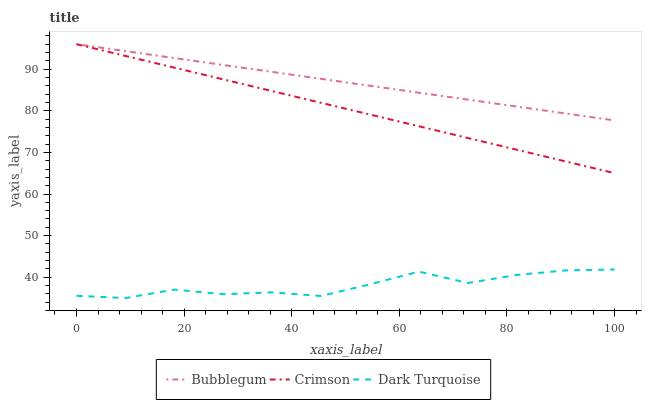Does Dark Turquoise have the minimum area under the curve?
Answer yes or no. Yes. Does Bubblegum have the maximum area under the curve?
Answer yes or no. Yes. Does Bubblegum have the minimum area under the curve?
Answer yes or no. No. Does Dark Turquoise have the maximum area under the curve?
Answer yes or no. No. Is Bubblegum the smoothest?
Answer yes or no. Yes. Is Dark Turquoise the roughest?
Answer yes or no. Yes. Is Dark Turquoise the smoothest?
Answer yes or no. No. Is Bubblegum the roughest?
Answer yes or no. No. Does Dark Turquoise have the lowest value?
Answer yes or no. Yes. Does Bubblegum have the lowest value?
Answer yes or no. No. Does Bubblegum have the highest value?
Answer yes or no. Yes. Does Dark Turquoise have the highest value?
Answer yes or no. No. Is Dark Turquoise less than Bubblegum?
Answer yes or no. Yes. Is Crimson greater than Dark Turquoise?
Answer yes or no. Yes. Does Crimson intersect Bubblegum?
Answer yes or no. Yes. Is Crimson less than Bubblegum?
Answer yes or no. No. Is Crimson greater than Bubblegum?
Answer yes or no. No. Does Dark Turquoise intersect Bubblegum?
Answer yes or no. No. 